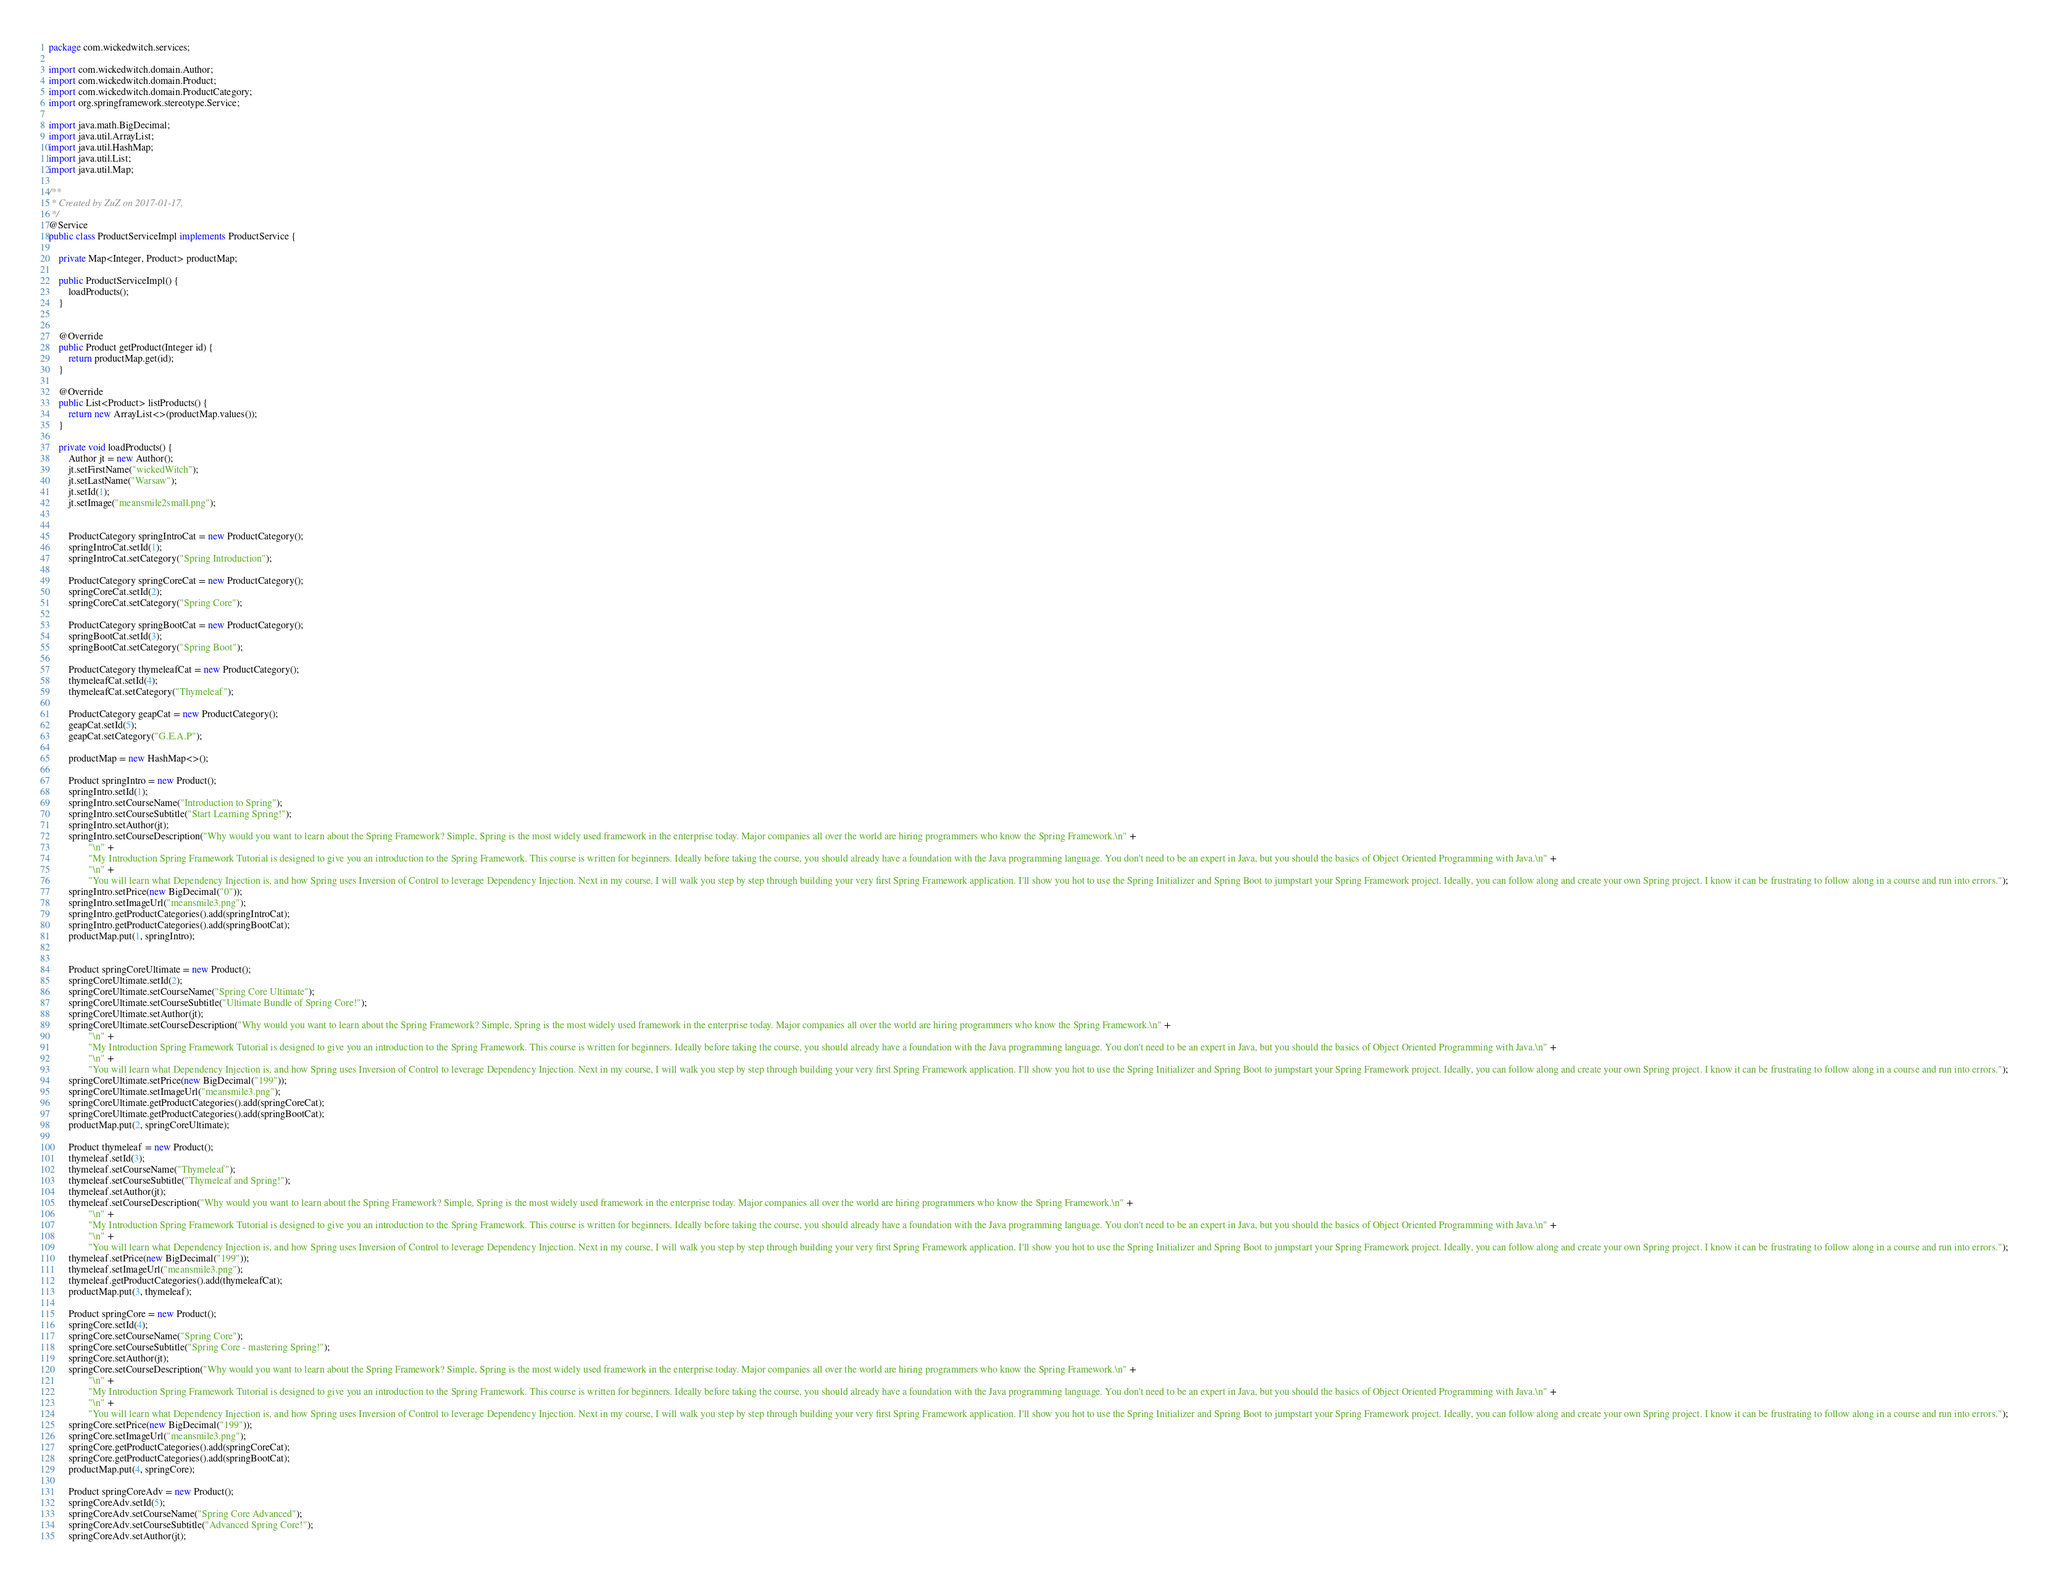Convert code to text. <code><loc_0><loc_0><loc_500><loc_500><_Java_>package com.wickedwitch.services;

import com.wickedwitch.domain.Author;
import com.wickedwitch.domain.Product;
import com.wickedwitch.domain.ProductCategory;
import org.springframework.stereotype.Service;

import java.math.BigDecimal;
import java.util.ArrayList;
import java.util.HashMap;
import java.util.List;
import java.util.Map;

/**
 * Created by ZuZ on 2017-01-17.
 */
@Service
public class ProductServiceImpl implements ProductService {

    private Map<Integer, Product> productMap;

    public ProductServiceImpl() {
        loadProducts();
    }


    @Override
    public Product getProduct(Integer id) {
        return productMap.get(id);
    }

    @Override
    public List<Product> listProducts() {
        return new ArrayList<>(productMap.values());
    }

    private void loadProducts() {
        Author jt = new Author();
        jt.setFirstName("wickedWitch");
        jt.setLastName("Warsaw");
        jt.setId(1);
        jt.setImage("meansmile2small.png");


        ProductCategory springIntroCat = new ProductCategory();
        springIntroCat.setId(1);
        springIntroCat.setCategory("Spring Introduction");

        ProductCategory springCoreCat = new ProductCategory();
        springCoreCat.setId(2);
        springCoreCat.setCategory("Spring Core");

        ProductCategory springBootCat = new ProductCategory();
        springBootCat.setId(3);
        springBootCat.setCategory("Spring Boot");

        ProductCategory thymeleafCat = new ProductCategory();
        thymeleafCat.setId(4);
        thymeleafCat.setCategory("Thymeleaf");

        ProductCategory geapCat = new ProductCategory();
        geapCat.setId(5);
        geapCat.setCategory("G.E.A.P");

        productMap = new HashMap<>();

        Product springIntro = new Product();
        springIntro.setId(1);
        springIntro.setCourseName("Introduction to Spring");
        springIntro.setCourseSubtitle("Start Learning Spring!");
        springIntro.setAuthor(jt);
        springIntro.setCourseDescription("Why would you want to learn about the Spring Framework? Simple, Spring is the most widely used framework in the enterprise today. Major companies all over the world are hiring programmers who know the Spring Framework.\n" +
                "\n" +
                "My Introduction Spring Framework Tutorial is designed to give you an introduction to the Spring Framework. This course is written for beginners. Ideally before taking the course, you should already have a foundation with the Java programming language. You don't need to be an expert in Java, but you should the basics of Object Oriented Programming with Java.\n" +
                "\n" +
                "You will learn what Dependency Injection is, and how Spring uses Inversion of Control to leverage Dependency Injection. Next in my course, I will walk you step by step through building your very first Spring Framework application. I'll show you hot to use the Spring Initializer and Spring Boot to jumpstart your Spring Framework project. Ideally, you can follow along and create your own Spring project. I know it can be frustrating to follow along in a course and run into errors.");
        springIntro.setPrice(new BigDecimal("0"));
        springIntro.setImageUrl("meansmile3.png");
        springIntro.getProductCategories().add(springIntroCat);
        springIntro.getProductCategories().add(springBootCat);
        productMap.put(1, springIntro);


        Product springCoreUltimate = new Product();
        springCoreUltimate.setId(2);
        springCoreUltimate.setCourseName("Spring Core Ultimate");
        springCoreUltimate.setCourseSubtitle("Ultimate Bundle of Spring Core!");
        springCoreUltimate.setAuthor(jt);
        springCoreUltimate.setCourseDescription("Why would you want to learn about the Spring Framework? Simple, Spring is the most widely used framework in the enterprise today. Major companies all over the world are hiring programmers who know the Spring Framework.\n" +
                "\n" +
                "My Introduction Spring Framework Tutorial is designed to give you an introduction to the Spring Framework. This course is written for beginners. Ideally before taking the course, you should already have a foundation with the Java programming language. You don't need to be an expert in Java, but you should the basics of Object Oriented Programming with Java.\n" +
                "\n" +
                "You will learn what Dependency Injection is, and how Spring uses Inversion of Control to leverage Dependency Injection. Next in my course, I will walk you step by step through building your very first Spring Framework application. I'll show you hot to use the Spring Initializer and Spring Boot to jumpstart your Spring Framework project. Ideally, you can follow along and create your own Spring project. I know it can be frustrating to follow along in a course and run into errors.");
        springCoreUltimate.setPrice(new BigDecimal("199"));
        springCoreUltimate.setImageUrl("meansmile3.png");
        springCoreUltimate.getProductCategories().add(springCoreCat);
        springCoreUltimate.getProductCategories().add(springBootCat);
        productMap.put(2, springCoreUltimate);

        Product thymeleaf = new Product();
        thymeleaf.setId(3);
        thymeleaf.setCourseName("Thymeleaf");
        thymeleaf.setCourseSubtitle("Thymeleaf and Spring!");
        thymeleaf.setAuthor(jt);
        thymeleaf.setCourseDescription("Why would you want to learn about the Spring Framework? Simple, Spring is the most widely used framework in the enterprise today. Major companies all over the world are hiring programmers who know the Spring Framework.\n" +
                "\n" +
                "My Introduction Spring Framework Tutorial is designed to give you an introduction to the Spring Framework. This course is written for beginners. Ideally before taking the course, you should already have a foundation with the Java programming language. You don't need to be an expert in Java, but you should the basics of Object Oriented Programming with Java.\n" +
                "\n" +
                "You will learn what Dependency Injection is, and how Spring uses Inversion of Control to leverage Dependency Injection. Next in my course, I will walk you step by step through building your very first Spring Framework application. I'll show you hot to use the Spring Initializer and Spring Boot to jumpstart your Spring Framework project. Ideally, you can follow along and create your own Spring project. I know it can be frustrating to follow along in a course and run into errors.");
        thymeleaf.setPrice(new BigDecimal("199"));
        thymeleaf.setImageUrl("meansmile3.png");
        thymeleaf.getProductCategories().add(thymeleafCat);
        productMap.put(3, thymeleaf);

        Product springCore = new Product();
        springCore.setId(4);
        springCore.setCourseName("Spring Core");
        springCore.setCourseSubtitle("Spring Core - mastering Spring!");
        springCore.setAuthor(jt);
        springCore.setCourseDescription("Why would you want to learn about the Spring Framework? Simple, Spring is the most widely used framework in the enterprise today. Major companies all over the world are hiring programmers who know the Spring Framework.\n" +
                "\n" +
                "My Introduction Spring Framework Tutorial is designed to give you an introduction to the Spring Framework. This course is written for beginners. Ideally before taking the course, you should already have a foundation with the Java programming language. You don't need to be an expert in Java, but you should the basics of Object Oriented Programming with Java.\n" +
                "\n" +
                "You will learn what Dependency Injection is, and how Spring uses Inversion of Control to leverage Dependency Injection. Next in my course, I will walk you step by step through building your very first Spring Framework application. I'll show you hot to use the Spring Initializer and Spring Boot to jumpstart your Spring Framework project. Ideally, you can follow along and create your own Spring project. I know it can be frustrating to follow along in a course and run into errors.");
        springCore.setPrice(new BigDecimal("199"));
        springCore.setImageUrl("meansmile3.png");
        springCore.getProductCategories().add(springCoreCat);
        springCore.getProductCategories().add(springBootCat);
        productMap.put(4, springCore);

        Product springCoreAdv = new Product();
        springCoreAdv.setId(5);
        springCoreAdv.setCourseName("Spring Core Advanced");
        springCoreAdv.setCourseSubtitle("Advanced Spring Core!");
        springCoreAdv.setAuthor(jt);</code> 